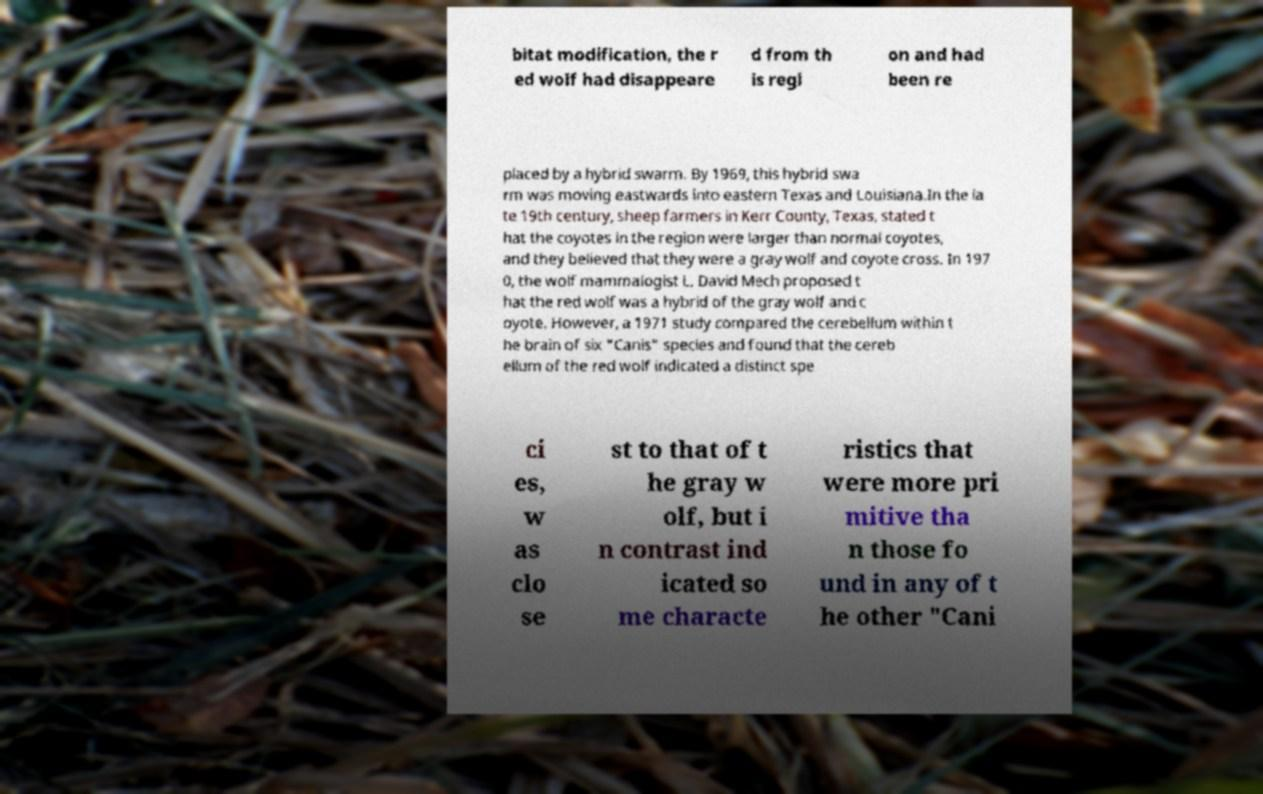Can you read and provide the text displayed in the image?This photo seems to have some interesting text. Can you extract and type it out for me? bitat modification, the r ed wolf had disappeare d from th is regi on and had been re placed by a hybrid swarm. By 1969, this hybrid swa rm was moving eastwards into eastern Texas and Louisiana.In the la te 19th century, sheep farmers in Kerr County, Texas, stated t hat the coyotes in the region were larger than normal coyotes, and they believed that they were a gray wolf and coyote cross. In 197 0, the wolf mammalogist L. David Mech proposed t hat the red wolf was a hybrid of the gray wolf and c oyote. However, a 1971 study compared the cerebellum within t he brain of six "Canis" species and found that the cereb ellum of the red wolf indicated a distinct spe ci es, w as clo se st to that of t he gray w olf, but i n contrast ind icated so me characte ristics that were more pri mitive tha n those fo und in any of t he other "Cani 